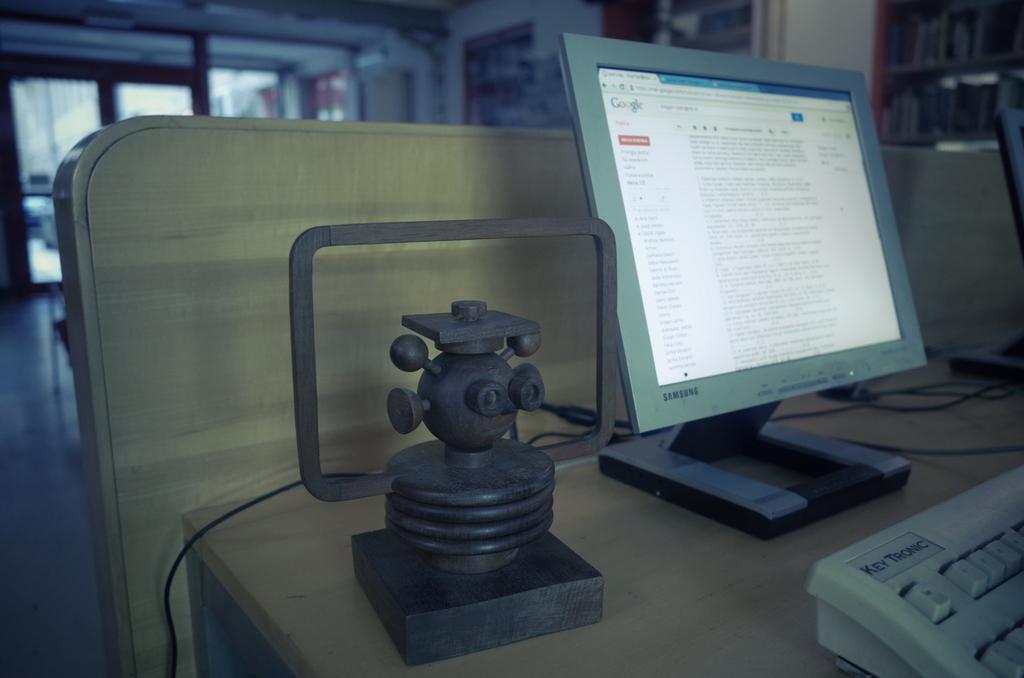What type of computer is this?
Your answer should be very brief. Samsung. 